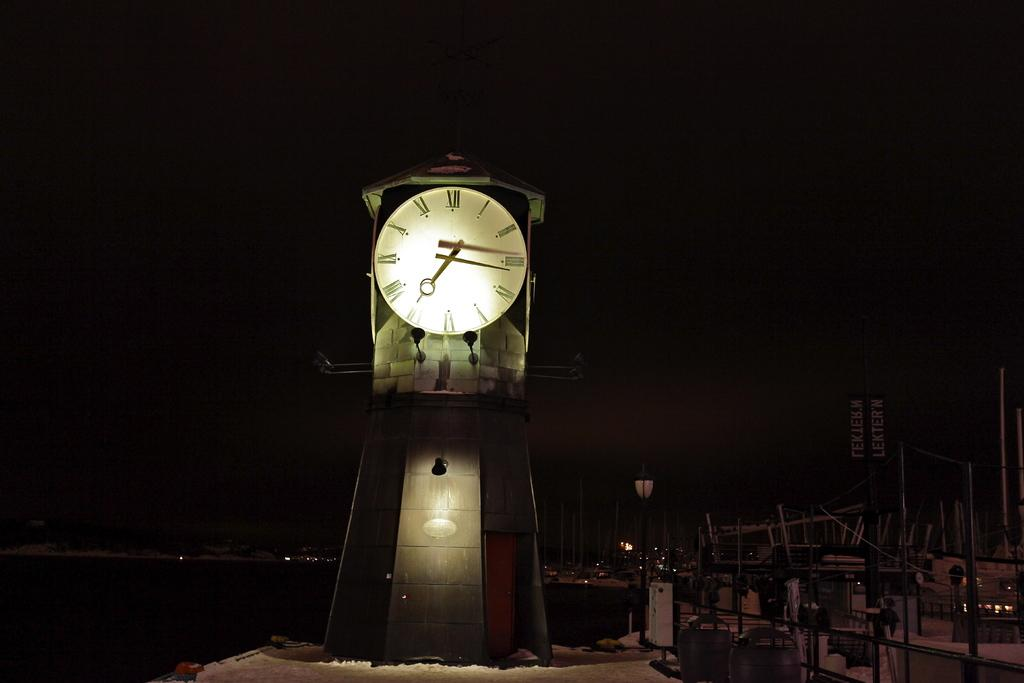Provide a one-sentence caption for the provided image. A large analog clock lit up at night. 